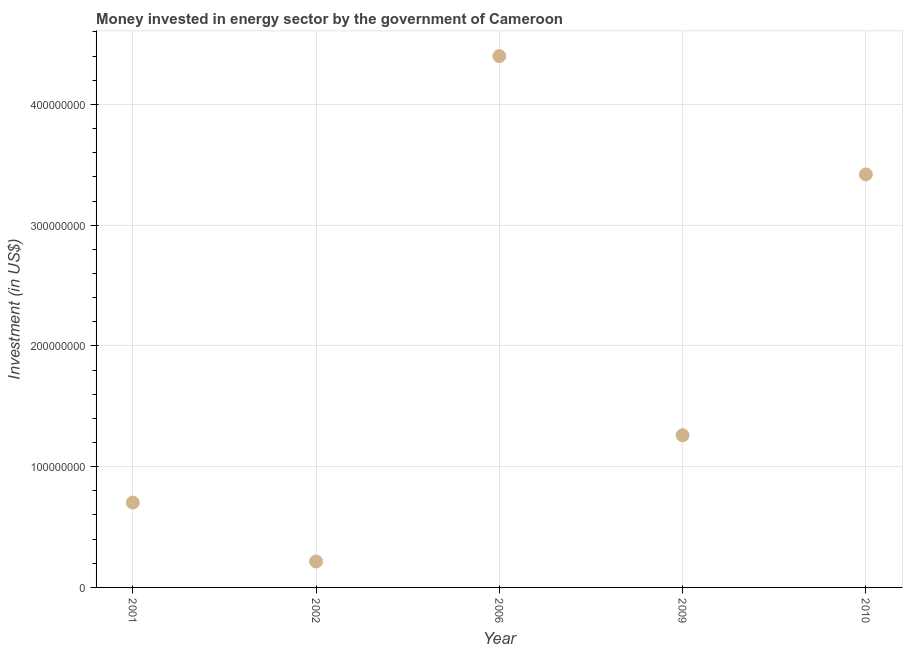What is the investment in energy in 2001?
Offer a terse response. 7.03e+07. Across all years, what is the maximum investment in energy?
Give a very brief answer. 4.40e+08. Across all years, what is the minimum investment in energy?
Offer a very short reply. 2.15e+07. What is the sum of the investment in energy?
Make the answer very short. 1.00e+09. What is the difference between the investment in energy in 2001 and 2002?
Give a very brief answer. 4.88e+07. What is the average investment in energy per year?
Make the answer very short. 2.00e+08. What is the median investment in energy?
Offer a terse response. 1.26e+08. Do a majority of the years between 2006 and 2001 (inclusive) have investment in energy greater than 200000000 US$?
Your answer should be very brief. No. What is the ratio of the investment in energy in 2002 to that in 2006?
Your answer should be very brief. 0.05. Is the investment in energy in 2002 less than that in 2009?
Keep it short and to the point. Yes. What is the difference between the highest and the second highest investment in energy?
Ensure brevity in your answer.  9.80e+07. Is the sum of the investment in energy in 2006 and 2009 greater than the maximum investment in energy across all years?
Your answer should be very brief. Yes. What is the difference between the highest and the lowest investment in energy?
Make the answer very short. 4.18e+08. Does the investment in energy monotonically increase over the years?
Provide a succinct answer. No. How many dotlines are there?
Keep it short and to the point. 1. How many years are there in the graph?
Give a very brief answer. 5. What is the difference between two consecutive major ticks on the Y-axis?
Your response must be concise. 1.00e+08. Does the graph contain any zero values?
Provide a succinct answer. No. Does the graph contain grids?
Your answer should be compact. Yes. What is the title of the graph?
Give a very brief answer. Money invested in energy sector by the government of Cameroon. What is the label or title of the X-axis?
Keep it short and to the point. Year. What is the label or title of the Y-axis?
Provide a short and direct response. Investment (in US$). What is the Investment (in US$) in 2001?
Provide a succinct answer. 7.03e+07. What is the Investment (in US$) in 2002?
Give a very brief answer. 2.15e+07. What is the Investment (in US$) in 2006?
Ensure brevity in your answer.  4.40e+08. What is the Investment (in US$) in 2009?
Provide a short and direct response. 1.26e+08. What is the Investment (in US$) in 2010?
Your answer should be compact. 3.42e+08. What is the difference between the Investment (in US$) in 2001 and 2002?
Provide a succinct answer. 4.88e+07. What is the difference between the Investment (in US$) in 2001 and 2006?
Offer a very short reply. -3.70e+08. What is the difference between the Investment (in US$) in 2001 and 2009?
Provide a succinct answer. -5.57e+07. What is the difference between the Investment (in US$) in 2001 and 2010?
Provide a succinct answer. -2.72e+08. What is the difference between the Investment (in US$) in 2002 and 2006?
Provide a succinct answer. -4.18e+08. What is the difference between the Investment (in US$) in 2002 and 2009?
Your answer should be very brief. -1.04e+08. What is the difference between the Investment (in US$) in 2002 and 2010?
Offer a very short reply. -3.20e+08. What is the difference between the Investment (in US$) in 2006 and 2009?
Your answer should be compact. 3.14e+08. What is the difference between the Investment (in US$) in 2006 and 2010?
Offer a very short reply. 9.80e+07. What is the difference between the Investment (in US$) in 2009 and 2010?
Provide a short and direct response. -2.16e+08. What is the ratio of the Investment (in US$) in 2001 to that in 2002?
Make the answer very short. 3.27. What is the ratio of the Investment (in US$) in 2001 to that in 2006?
Your answer should be very brief. 0.16. What is the ratio of the Investment (in US$) in 2001 to that in 2009?
Offer a terse response. 0.56. What is the ratio of the Investment (in US$) in 2001 to that in 2010?
Provide a succinct answer. 0.21. What is the ratio of the Investment (in US$) in 2002 to that in 2006?
Your answer should be very brief. 0.05. What is the ratio of the Investment (in US$) in 2002 to that in 2009?
Make the answer very short. 0.17. What is the ratio of the Investment (in US$) in 2002 to that in 2010?
Provide a succinct answer. 0.06. What is the ratio of the Investment (in US$) in 2006 to that in 2009?
Keep it short and to the point. 3.49. What is the ratio of the Investment (in US$) in 2006 to that in 2010?
Make the answer very short. 1.29. What is the ratio of the Investment (in US$) in 2009 to that in 2010?
Your response must be concise. 0.37. 